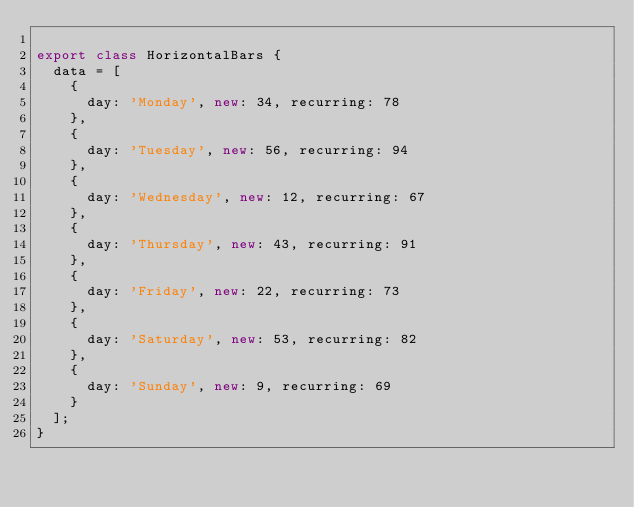Convert code to text. <code><loc_0><loc_0><loc_500><loc_500><_JavaScript_>
export class HorizontalBars {
  data = [
    {
      day: 'Monday', new: 34, recurring: 78
    },
    {
      day: 'Tuesday', new: 56, recurring: 94
    },
    {
      day: 'Wednesday', new: 12, recurring: 67
    },
    {
      day: 'Thursday', new: 43, recurring: 91
    },
    {
      day: 'Friday', new: 22, recurring: 73
    },
    {
      day: 'Saturday', new: 53, recurring: 82
    },
    {
      day: 'Sunday', new: 9, recurring: 69
    }
  ];
}
</code> 